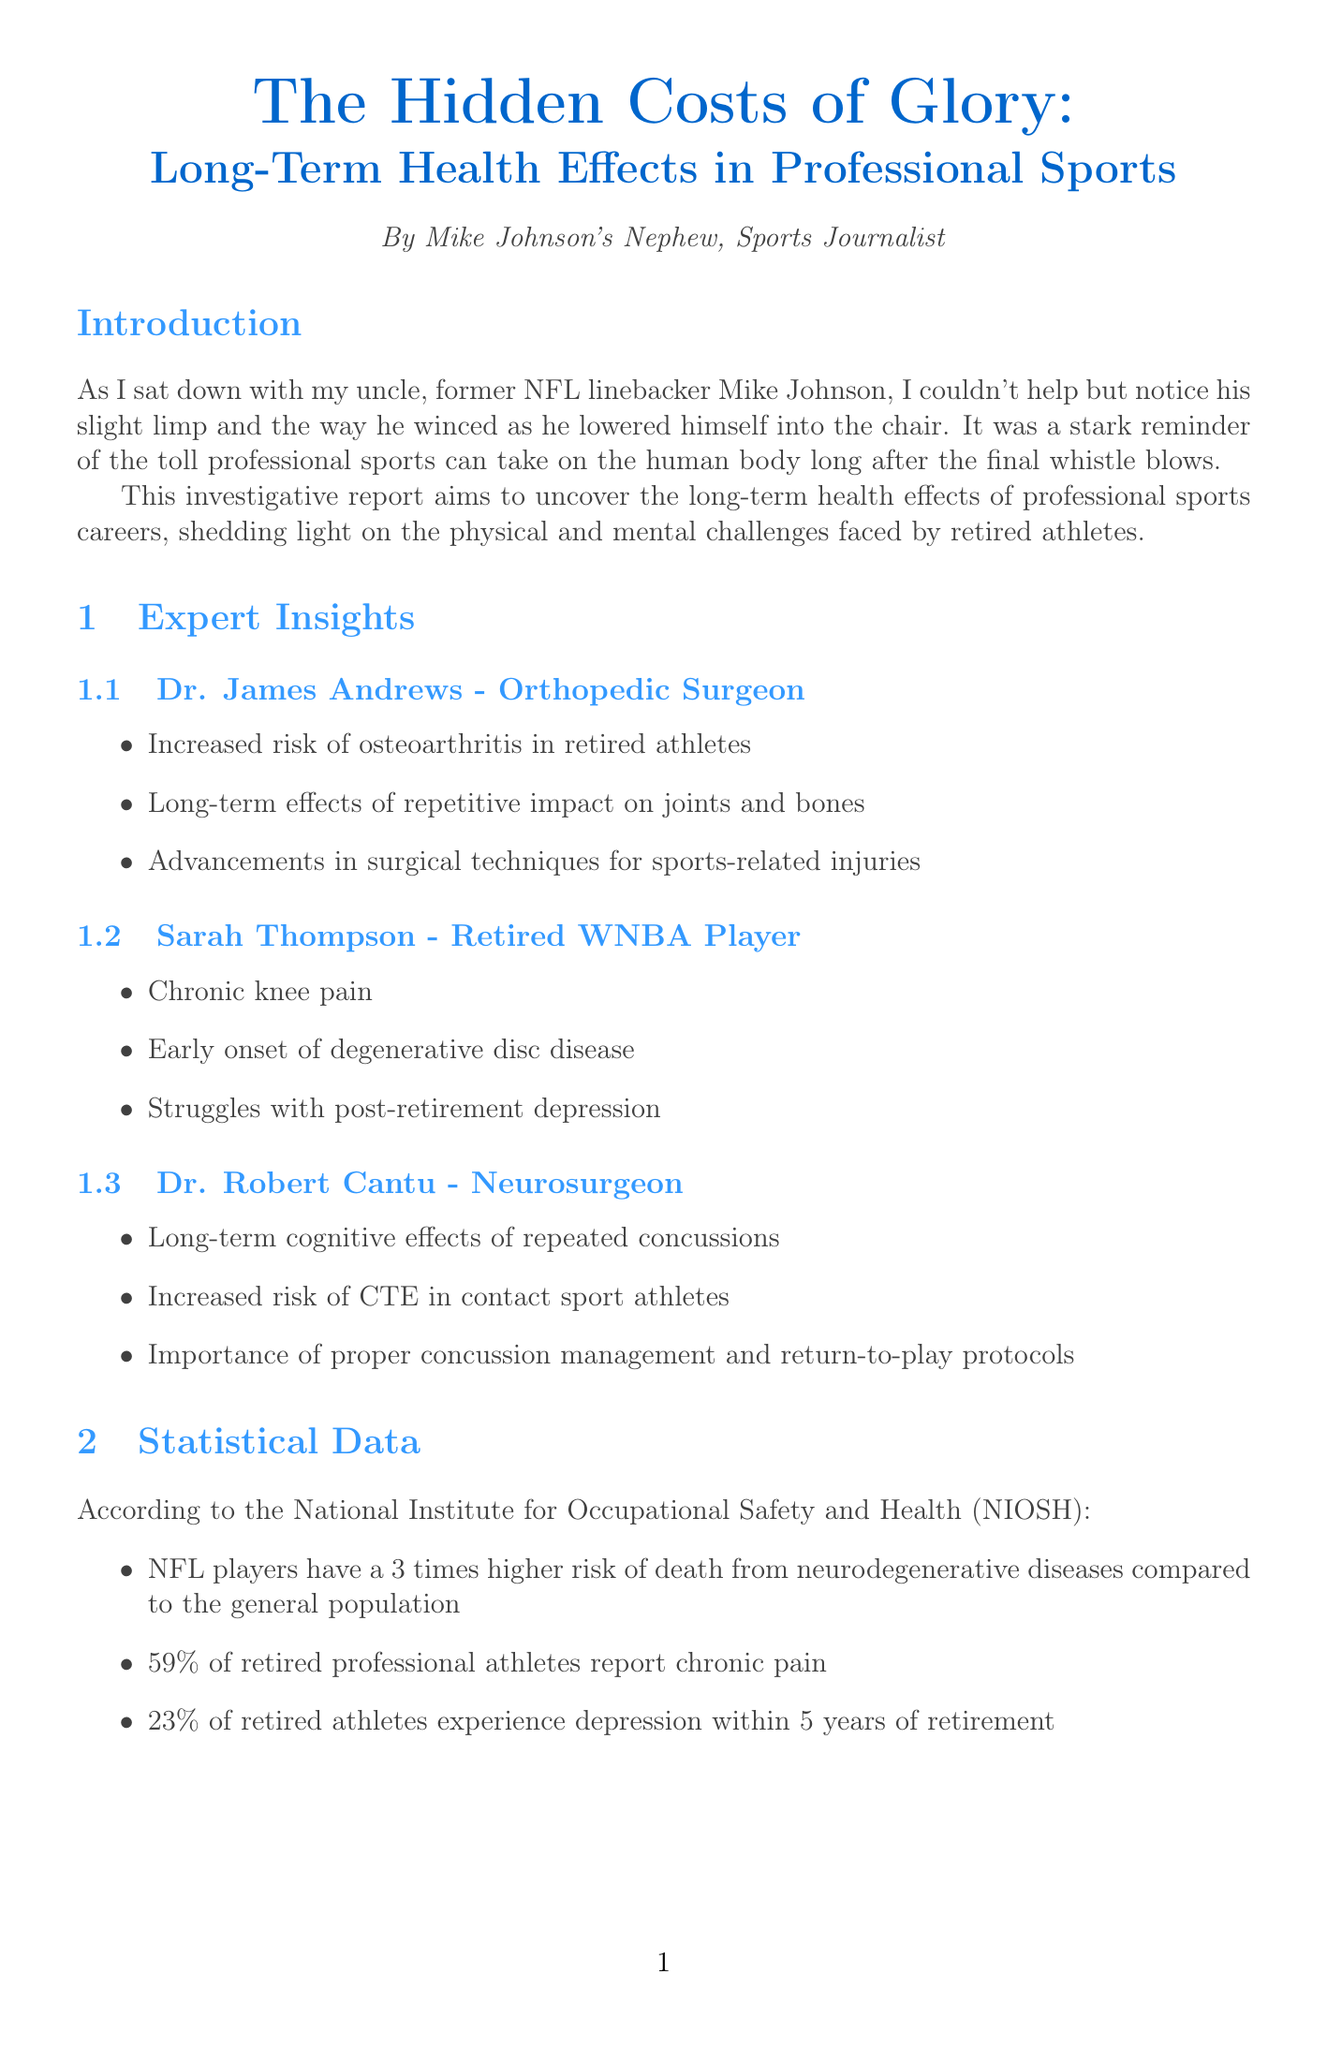What is the title of the report? The title of the report is stated prominently at the beginning of the document.
Answer: The Hidden Costs of Glory: Long-Term Health Effects in Professional Sports Who is the author of the report? The author is mentioned in the document, specifically in the introduction section.
Answer: Mike Johnson's Nephew What profession does Dr. James Andrews have? The document specifies the profession of Dr. James Andrews in the expert insights section.
Answer: Orthopedic Surgeon What percentage of retired professional athletes report chronic pain? The document includes statistical data that quantifies the issue of chronic pain among retired athletes.
Answer: 59% What health issue does Sarah Thompson face? The document lists health issues experienced by Sarah Thompson, a retired athlete, in her insights.
Answer: Chronic knee pain What is Mike Johnson's advice to young athletes? The document cites the personal advice given by Mike Johnson regarding long-term health in sports.
Answer: Prioritize their long-term health over short-term glory What are the long-term cognitive effects mentioned by Dr. Robert Cantu? The document includes insights from Dr. Cantu regarding cognitive effects in athletes.
Answer: Repeated concussions What emerging trend involves the establishment of health programs? The document discusses new developments in athlete health and wellness.
Answer: Post-career health programs How much higher is the risk of neurodegenerative diseases for NFL players compared to the general population? The document provides a specific statistic relating to NFL players and neurodegenerative diseases.
Answer: 3 times higher 